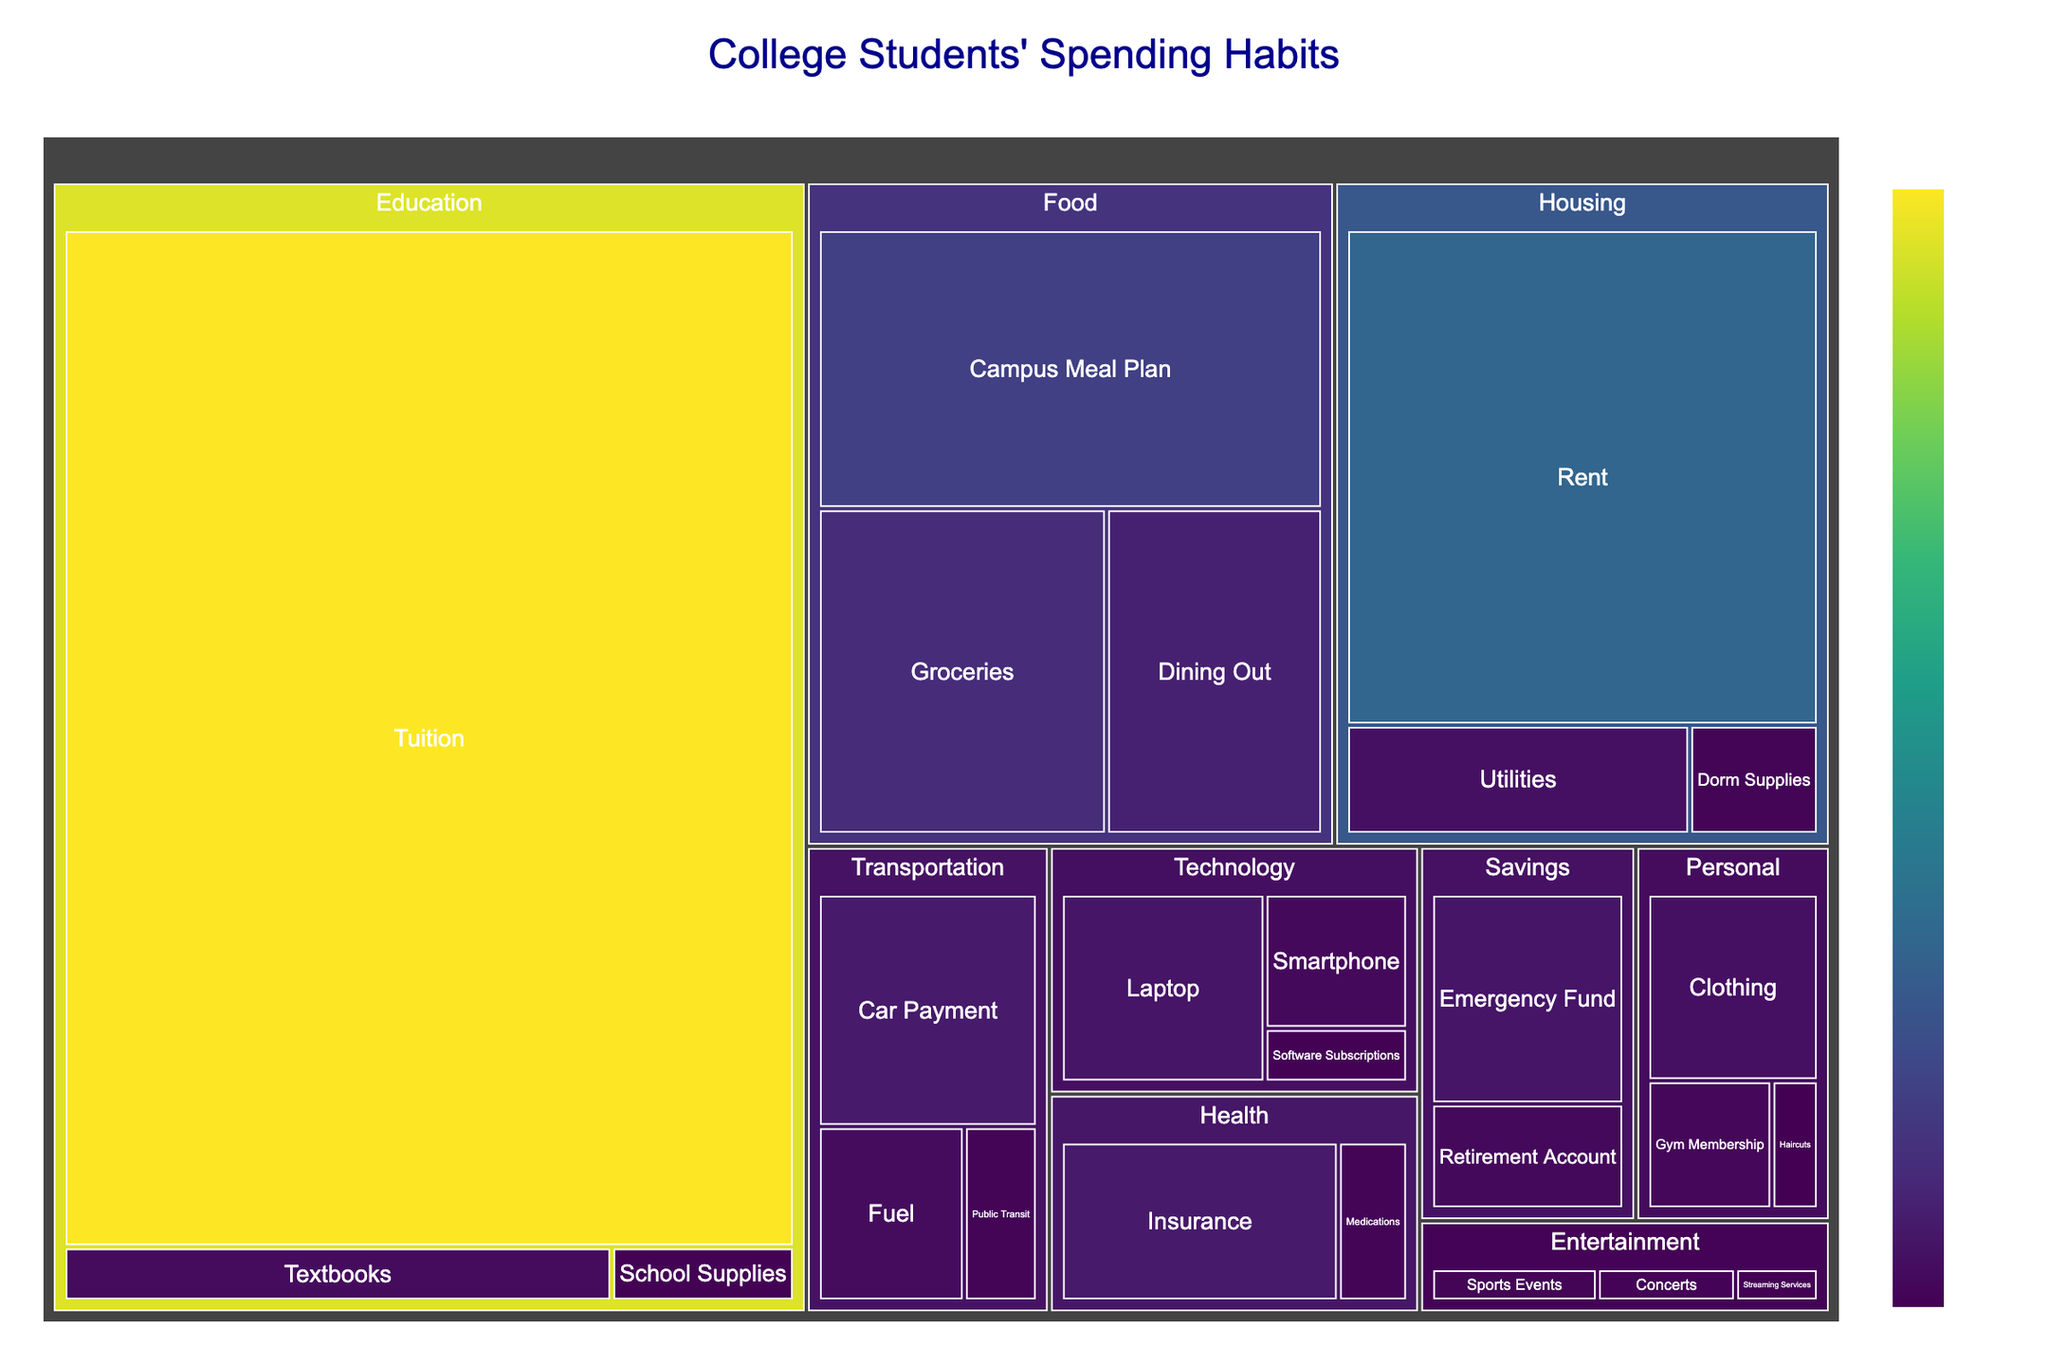What is the total amount spent on Housing? To find the total amount spent on Housing, we need to sum the amounts for Rent, Utilities, and Dorm Supplies. Housing: Rent ($5000) + Utilities ($800) + Dorm Supplies ($300) = $6100.
Answer: $6100 Among all expense categories, which one has the highest spending? The category with the largest amount in the treemap is Education, with Tuition alone amounting to $15000. Adding Textbooks ($600) and School Supplies ($200) further confirms Education's dominance.
Answer: Education Which subcategory under Food has the highest spending? Within the Food category, Groceries ($2000), Dining Out ($1500), and Campus Meal Plan ($3000), the Campus Meal Plan has the highest spending.
Answer: Campus Meal Plan How does the spending on Entertainment – Sports Events compare to Entertainment – Concerts? To compare these subcategories, look at their amounts: Sports Events ($300) and Concerts ($250). Sports Events spending is greater.
Answer: Sports Events What is the combined spending on Technology? Sum the amounts for Laptop, Smartphone, and Software Subscriptions: Laptop ($1000) + Smartphone ($500) + Software Subscriptions ($200) = $1700.
Answer: $1700 Which category has the lowest total spending amount? To find the lowest spending category, compare the totals: Housing ($6100), Education ($15800), Food ($6500), Transportation ($2100), Personal ($1350), Technology ($1700), Entertainment ($700), Savings ($1500), Health ($1500). The category with the smallest spending is Entertainment ($700).
Answer: Entertainment Which cost more: Health or Savings? Compare the totals for Health and Savings: Health ($1500) vs. Savings ($1500). They have equal spending.
Answer: They are equal What is the average amount spent on Personal category subcategories? Personal category's subcategories are Clothing ($800), Gym Membership ($400), and Haircuts ($150). The average is ($800 + $400 + $150) / 3 categories = $1350 / 3 = $450.
Answer: $450 What is the largest single expense subcategory in the treemap? By examining all subcategory values, the one with the maximum amount is Tuition under Education at $15000.
Answer: Tuition How much more is spent on Groceries compared to Utilities? Compare the amounts: Groceries ($2000) - Utilities ($800) = $1200.
Answer: $1200 